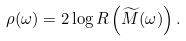<formula> <loc_0><loc_0><loc_500><loc_500>\rho ( \omega ) = 2 \log R \left ( \widetilde { M } ( \omega ) \right ) .</formula> 